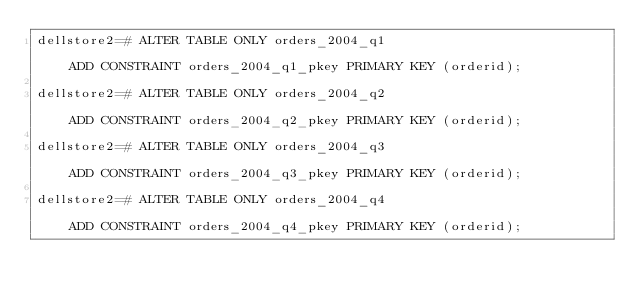Convert code to text. <code><loc_0><loc_0><loc_500><loc_500><_SQL_>dellstore2=# ALTER TABLE ONLY orders_2004_q1                                                                                                                                                                             ADD CONSTRAINT orders_2004_q1_pkey PRIMARY KEY (orderid);

dellstore2=# ALTER TABLE ONLY orders_2004_q2                                                                                                                                                                             ADD CONSTRAINT orders_2004_q2_pkey PRIMARY KEY (orderid);

dellstore2=# ALTER TABLE ONLY orders_2004_q3                                                                                                                                                                             ADD CONSTRAINT orders_2004_q3_pkey PRIMARY KEY (orderid);

dellstore2=# ALTER TABLE ONLY orders_2004_q4                                                                                                                                                                             ADD CONSTRAINT orders_2004_q4_pkey PRIMARY KEY (orderid);

</code> 